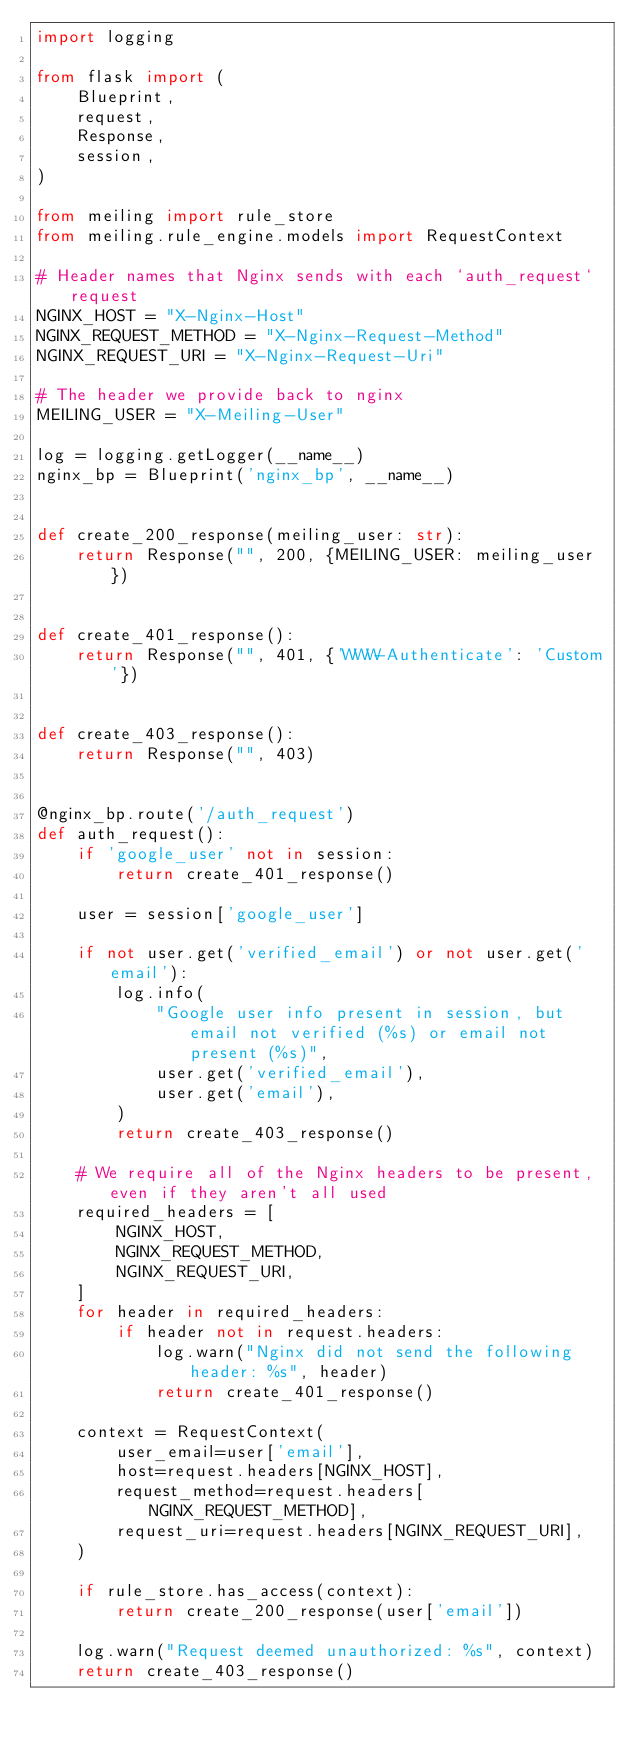Convert code to text. <code><loc_0><loc_0><loc_500><loc_500><_Python_>import logging

from flask import (
    Blueprint,
    request,
    Response,
    session,
)

from meiling import rule_store
from meiling.rule_engine.models import RequestContext

# Header names that Nginx sends with each `auth_request` request
NGINX_HOST = "X-Nginx-Host"
NGINX_REQUEST_METHOD = "X-Nginx-Request-Method"
NGINX_REQUEST_URI = "X-Nginx-Request-Uri"

# The header we provide back to nginx
MEILING_USER = "X-Meiling-User"

log = logging.getLogger(__name__)
nginx_bp = Blueprint('nginx_bp', __name__)


def create_200_response(meiling_user: str):
    return Response("", 200, {MEILING_USER: meiling_user})


def create_401_response():
    return Response("", 401, {'WWW-Authenticate': 'Custom'})


def create_403_response():
    return Response("", 403)


@nginx_bp.route('/auth_request')
def auth_request():
    if 'google_user' not in session:
        return create_401_response()

    user = session['google_user']

    if not user.get('verified_email') or not user.get('email'):
        log.info(
            "Google user info present in session, but email not verified (%s) or email not present (%s)",
            user.get('verified_email'),
            user.get('email'),
        )
        return create_403_response()

    # We require all of the Nginx headers to be present, even if they aren't all used
    required_headers = [
        NGINX_HOST,
        NGINX_REQUEST_METHOD,
        NGINX_REQUEST_URI,
    ]
    for header in required_headers:
        if header not in request.headers:
            log.warn("Nginx did not send the following header: %s", header)
            return create_401_response()

    context = RequestContext(
        user_email=user['email'],
        host=request.headers[NGINX_HOST],
        request_method=request.headers[NGINX_REQUEST_METHOD],
        request_uri=request.headers[NGINX_REQUEST_URI],
    )

    if rule_store.has_access(context):
        return create_200_response(user['email'])

    log.warn("Request deemed unauthorized: %s", context)
    return create_403_response()
</code> 